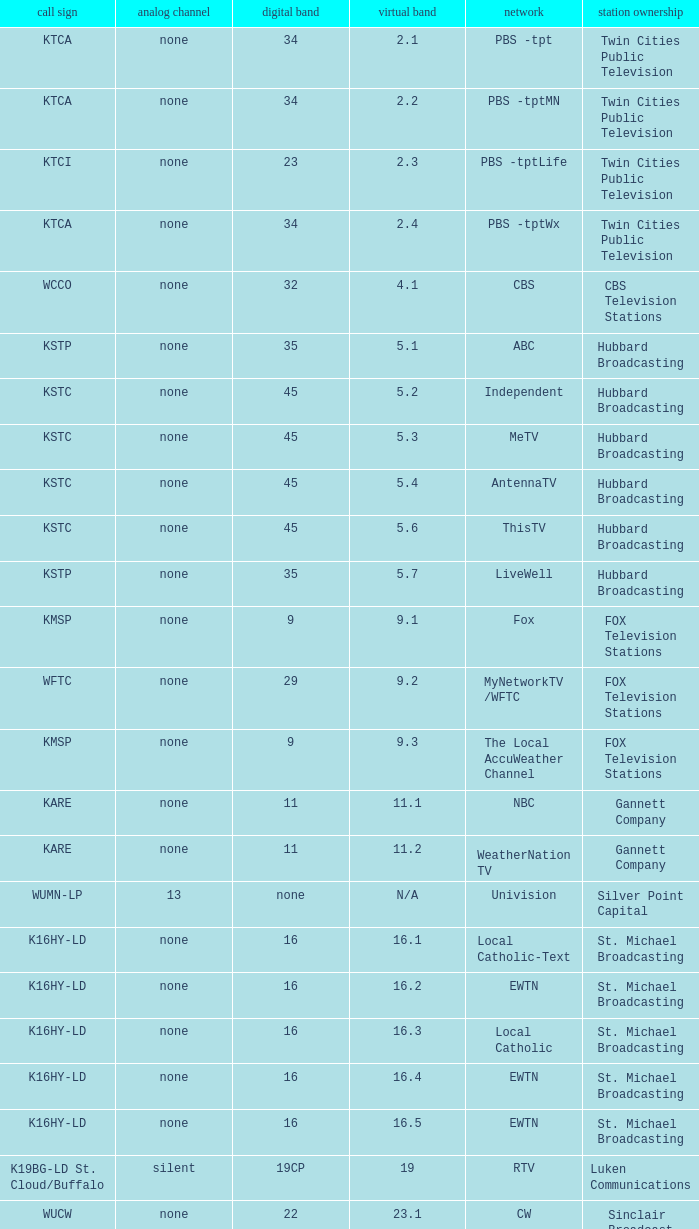Virtual channel of 16.5 has what call sign? K16HY-LD. 